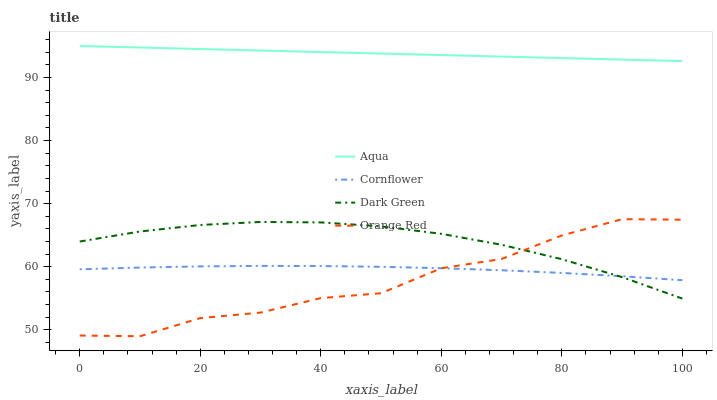Does Orange Red have the minimum area under the curve?
Answer yes or no. Yes. Does Aqua have the maximum area under the curve?
Answer yes or no. Yes. Does Aqua have the minimum area under the curve?
Answer yes or no. No. Does Orange Red have the maximum area under the curve?
Answer yes or no. No. Is Aqua the smoothest?
Answer yes or no. Yes. Is Orange Red the roughest?
Answer yes or no. Yes. Is Orange Red the smoothest?
Answer yes or no. No. Is Aqua the roughest?
Answer yes or no. No. Does Orange Red have the lowest value?
Answer yes or no. Yes. Does Aqua have the lowest value?
Answer yes or no. No. Does Aqua have the highest value?
Answer yes or no. Yes. Does Orange Red have the highest value?
Answer yes or no. No. Is Orange Red less than Aqua?
Answer yes or no. Yes. Is Aqua greater than Orange Red?
Answer yes or no. Yes. Does Orange Red intersect Dark Green?
Answer yes or no. Yes. Is Orange Red less than Dark Green?
Answer yes or no. No. Is Orange Red greater than Dark Green?
Answer yes or no. No. Does Orange Red intersect Aqua?
Answer yes or no. No. 